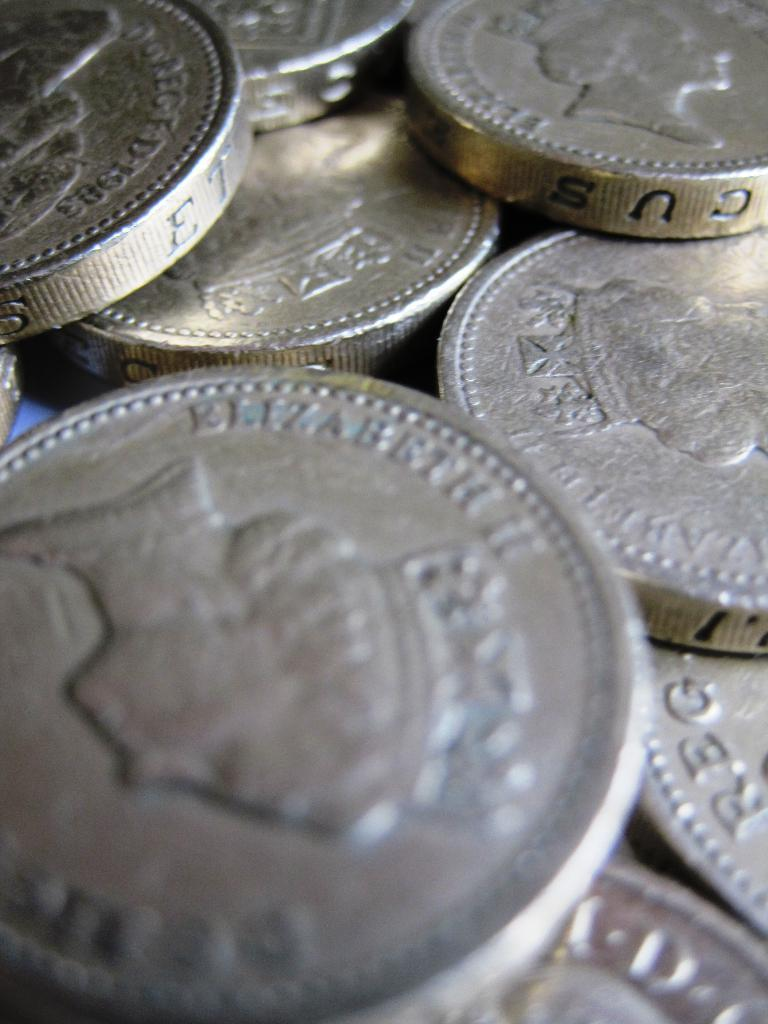<image>
Offer a succinct explanation of the picture presented. a bunch of silver coins with Elizabeth II wrote on them 